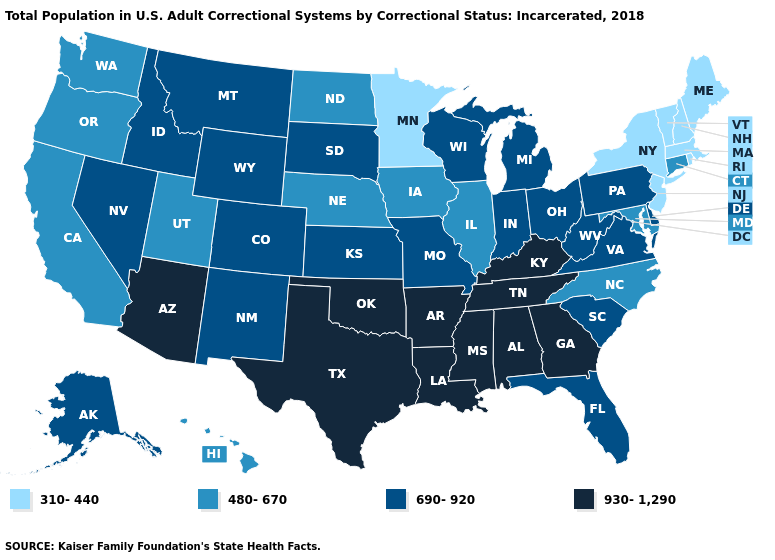What is the value of West Virginia?
Keep it brief. 690-920. Does the map have missing data?
Give a very brief answer. No. Name the states that have a value in the range 690-920?
Give a very brief answer. Alaska, Colorado, Delaware, Florida, Idaho, Indiana, Kansas, Michigan, Missouri, Montana, Nevada, New Mexico, Ohio, Pennsylvania, South Carolina, South Dakota, Virginia, West Virginia, Wisconsin, Wyoming. Does Texas have a higher value than Kentucky?
Answer briefly. No. Does the map have missing data?
Give a very brief answer. No. Which states have the lowest value in the USA?
Answer briefly. Maine, Massachusetts, Minnesota, New Hampshire, New Jersey, New York, Rhode Island, Vermont. Does Illinois have a higher value than Connecticut?
Answer briefly. No. Name the states that have a value in the range 930-1,290?
Write a very short answer. Alabama, Arizona, Arkansas, Georgia, Kentucky, Louisiana, Mississippi, Oklahoma, Tennessee, Texas. Does the first symbol in the legend represent the smallest category?
Answer briefly. Yes. What is the highest value in the USA?
Quick response, please. 930-1,290. Which states have the lowest value in the MidWest?
Give a very brief answer. Minnesota. What is the highest value in the USA?
Give a very brief answer. 930-1,290. What is the value of Utah?
Keep it brief. 480-670. What is the value of Utah?
Give a very brief answer. 480-670. What is the value of Delaware?
Be succinct. 690-920. 